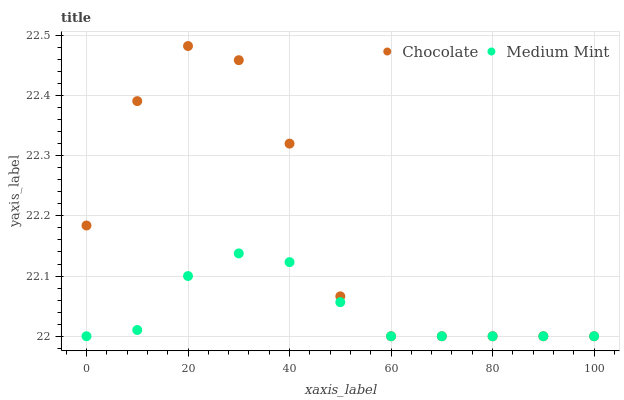Does Medium Mint have the minimum area under the curve?
Answer yes or no. Yes. Does Chocolate have the maximum area under the curve?
Answer yes or no. Yes. Does Chocolate have the minimum area under the curve?
Answer yes or no. No. Is Medium Mint the smoothest?
Answer yes or no. Yes. Is Chocolate the roughest?
Answer yes or no. Yes. Is Chocolate the smoothest?
Answer yes or no. No. Does Medium Mint have the lowest value?
Answer yes or no. Yes. Does Chocolate have the highest value?
Answer yes or no. Yes. Does Chocolate intersect Medium Mint?
Answer yes or no. Yes. Is Chocolate less than Medium Mint?
Answer yes or no. No. Is Chocolate greater than Medium Mint?
Answer yes or no. No. 